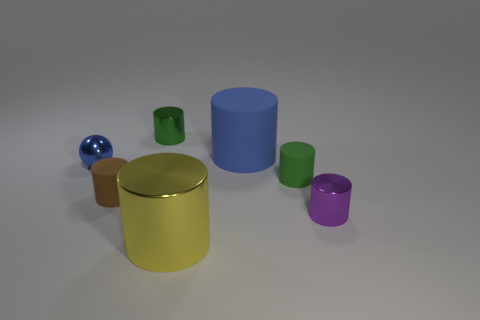There is a tiny sphere that is the same color as the big rubber object; what material is it?
Keep it short and to the point. Metal. Do the green metallic cylinder and the metal ball have the same size?
Ensure brevity in your answer.  Yes. Is the small metal ball the same color as the big shiny cylinder?
Provide a succinct answer. No. What is the material of the green cylinder that is in front of the big object that is on the right side of the yellow cylinder?
Offer a terse response. Rubber. There is a big blue object that is the same shape as the big yellow thing; what material is it?
Offer a terse response. Rubber. Do the thing in front of the purple cylinder and the big blue object have the same size?
Your response must be concise. Yes. What number of rubber objects are cyan objects or purple objects?
Your response must be concise. 0. There is a small cylinder that is both on the right side of the large metal cylinder and behind the brown object; what material is it?
Offer a terse response. Rubber. Is the sphere made of the same material as the purple cylinder?
Offer a very short reply. Yes. What is the size of the shiny cylinder that is in front of the green rubber thing and left of the purple shiny cylinder?
Offer a very short reply. Large. 